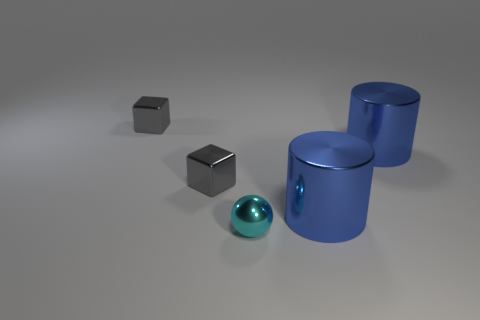Add 4 gray metallic blocks. How many objects exist? 9 Subtract all cubes. How many objects are left? 3 Add 2 small cyan metal things. How many small cyan metal things are left? 3 Add 2 big red matte balls. How many big red matte balls exist? 2 Subtract 0 green cylinders. How many objects are left? 5 Subtract all spheres. Subtract all tiny cyan spheres. How many objects are left? 3 